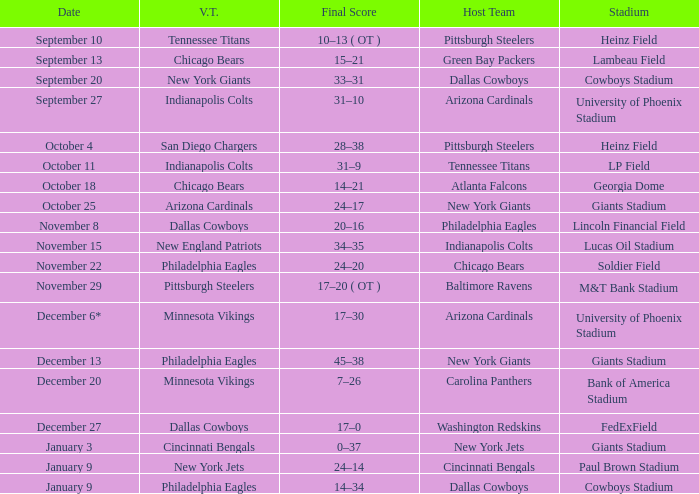Parse the table in full. {'header': ['Date', 'V.T.', 'Final Score', 'Host Team', 'Stadium'], 'rows': [['September 10', 'Tennessee Titans', '10–13 ( OT )', 'Pittsburgh Steelers', 'Heinz Field'], ['September 13', 'Chicago Bears', '15–21', 'Green Bay Packers', 'Lambeau Field'], ['September 20', 'New York Giants', '33–31', 'Dallas Cowboys', 'Cowboys Stadium'], ['September 27', 'Indianapolis Colts', '31–10', 'Arizona Cardinals', 'University of Phoenix Stadium'], ['October 4', 'San Diego Chargers', '28–38', 'Pittsburgh Steelers', 'Heinz Field'], ['October 11', 'Indianapolis Colts', '31–9', 'Tennessee Titans', 'LP Field'], ['October 18', 'Chicago Bears', '14–21', 'Atlanta Falcons', 'Georgia Dome'], ['October 25', 'Arizona Cardinals', '24–17', 'New York Giants', 'Giants Stadium'], ['November 8', 'Dallas Cowboys', '20–16', 'Philadelphia Eagles', 'Lincoln Financial Field'], ['November 15', 'New England Patriots', '34–35', 'Indianapolis Colts', 'Lucas Oil Stadium'], ['November 22', 'Philadelphia Eagles', '24–20', 'Chicago Bears', 'Soldier Field'], ['November 29', 'Pittsburgh Steelers', '17–20 ( OT )', 'Baltimore Ravens', 'M&T Bank Stadium'], ['December 6*', 'Minnesota Vikings', '17–30', 'Arizona Cardinals', 'University of Phoenix Stadium'], ['December 13', 'Philadelphia Eagles', '45–38', 'New York Giants', 'Giants Stadium'], ['December 20', 'Minnesota Vikings', '7–26', 'Carolina Panthers', 'Bank of America Stadium'], ['December 27', 'Dallas Cowboys', '17–0', 'Washington Redskins', 'FedExField'], ['January 3', 'Cincinnati Bengals', '0–37', 'New York Jets', 'Giants Stadium'], ['January 9', 'New York Jets', '24–14', 'Cincinnati Bengals', 'Paul Brown Stadium'], ['January 9', 'Philadelphia Eagles', '14–34', 'Dallas Cowboys', 'Cowboys Stadium']]} I want to know the final score for december 27 17–0. 